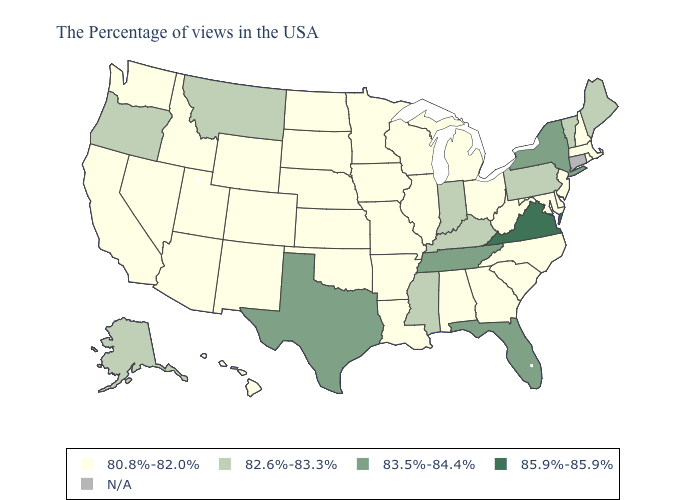What is the lowest value in the USA?
Short answer required. 80.8%-82.0%. Which states have the highest value in the USA?
Write a very short answer. Virginia. Which states have the lowest value in the MidWest?
Be succinct. Ohio, Michigan, Wisconsin, Illinois, Missouri, Minnesota, Iowa, Kansas, Nebraska, South Dakota, North Dakota. Which states have the lowest value in the USA?
Answer briefly. Massachusetts, Rhode Island, New Hampshire, New Jersey, Delaware, Maryland, North Carolina, South Carolina, West Virginia, Ohio, Georgia, Michigan, Alabama, Wisconsin, Illinois, Louisiana, Missouri, Arkansas, Minnesota, Iowa, Kansas, Nebraska, Oklahoma, South Dakota, North Dakota, Wyoming, Colorado, New Mexico, Utah, Arizona, Idaho, Nevada, California, Washington, Hawaii. What is the highest value in the West ?
Concise answer only. 82.6%-83.3%. What is the lowest value in the South?
Give a very brief answer. 80.8%-82.0%. Among the states that border South Carolina , which have the highest value?
Short answer required. North Carolina, Georgia. Name the states that have a value in the range N/A?
Be succinct. Connecticut. Is the legend a continuous bar?
Quick response, please. No. Does the map have missing data?
Short answer required. Yes. Does the map have missing data?
Short answer required. Yes. How many symbols are there in the legend?
Quick response, please. 5. Does the first symbol in the legend represent the smallest category?
Keep it brief. Yes. Which states hav the highest value in the South?
Keep it brief. Virginia. What is the value of Nevada?
Write a very short answer. 80.8%-82.0%. 